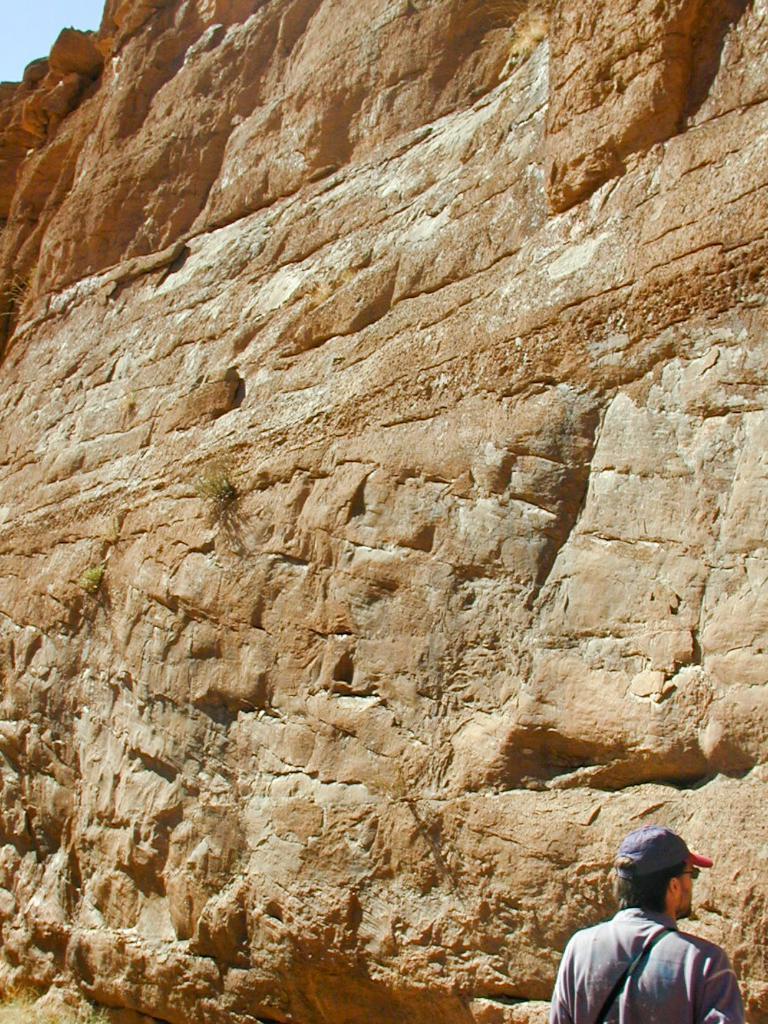How would you summarize this image in a sentence or two? Here we can see a man. In the background there is a mountain and sky. 